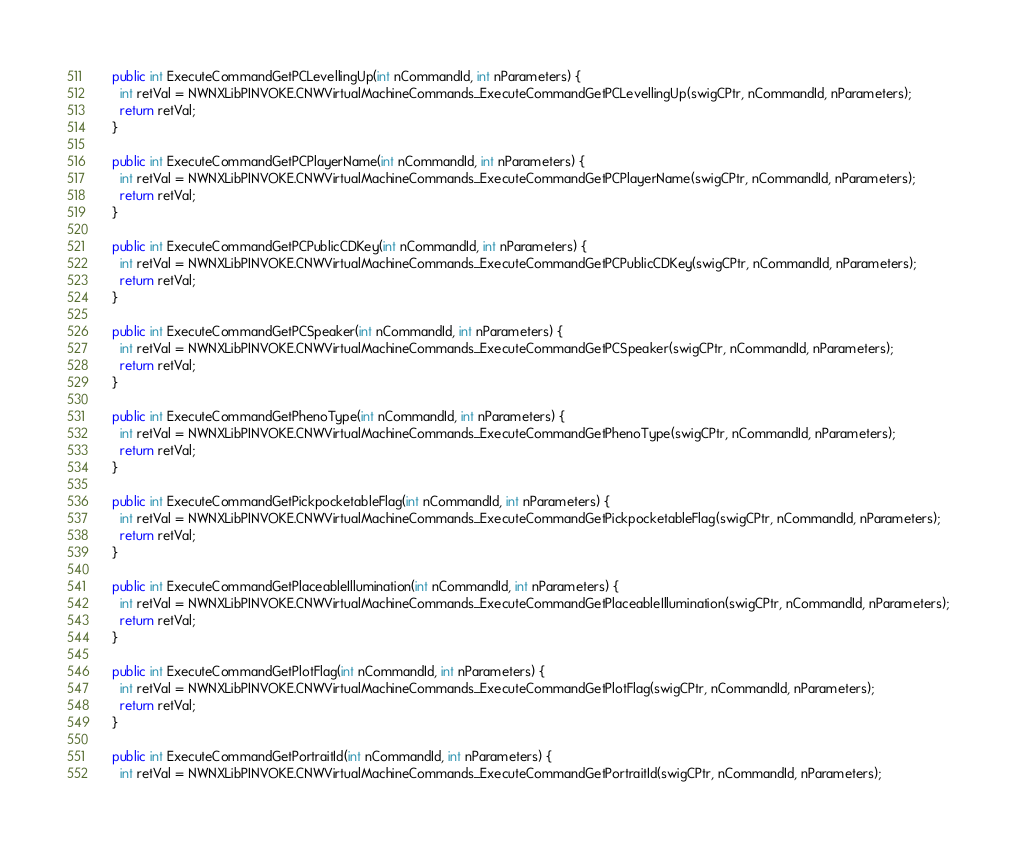<code> <loc_0><loc_0><loc_500><loc_500><_C#_>  public int ExecuteCommandGetPCLevellingUp(int nCommandId, int nParameters) {
    int retVal = NWNXLibPINVOKE.CNWVirtualMachineCommands_ExecuteCommandGetPCLevellingUp(swigCPtr, nCommandId, nParameters);
    return retVal;
  }

  public int ExecuteCommandGetPCPlayerName(int nCommandId, int nParameters) {
    int retVal = NWNXLibPINVOKE.CNWVirtualMachineCommands_ExecuteCommandGetPCPlayerName(swigCPtr, nCommandId, nParameters);
    return retVal;
  }

  public int ExecuteCommandGetPCPublicCDKey(int nCommandId, int nParameters) {
    int retVal = NWNXLibPINVOKE.CNWVirtualMachineCommands_ExecuteCommandGetPCPublicCDKey(swigCPtr, nCommandId, nParameters);
    return retVal;
  }

  public int ExecuteCommandGetPCSpeaker(int nCommandId, int nParameters) {
    int retVal = NWNXLibPINVOKE.CNWVirtualMachineCommands_ExecuteCommandGetPCSpeaker(swigCPtr, nCommandId, nParameters);
    return retVal;
  }

  public int ExecuteCommandGetPhenoType(int nCommandId, int nParameters) {
    int retVal = NWNXLibPINVOKE.CNWVirtualMachineCommands_ExecuteCommandGetPhenoType(swigCPtr, nCommandId, nParameters);
    return retVal;
  }

  public int ExecuteCommandGetPickpocketableFlag(int nCommandId, int nParameters) {
    int retVal = NWNXLibPINVOKE.CNWVirtualMachineCommands_ExecuteCommandGetPickpocketableFlag(swigCPtr, nCommandId, nParameters);
    return retVal;
  }

  public int ExecuteCommandGetPlaceableIllumination(int nCommandId, int nParameters) {
    int retVal = NWNXLibPINVOKE.CNWVirtualMachineCommands_ExecuteCommandGetPlaceableIllumination(swigCPtr, nCommandId, nParameters);
    return retVal;
  }

  public int ExecuteCommandGetPlotFlag(int nCommandId, int nParameters) {
    int retVal = NWNXLibPINVOKE.CNWVirtualMachineCommands_ExecuteCommandGetPlotFlag(swigCPtr, nCommandId, nParameters);
    return retVal;
  }

  public int ExecuteCommandGetPortraitId(int nCommandId, int nParameters) {
    int retVal = NWNXLibPINVOKE.CNWVirtualMachineCommands_ExecuteCommandGetPortraitId(swigCPtr, nCommandId, nParameters);</code> 